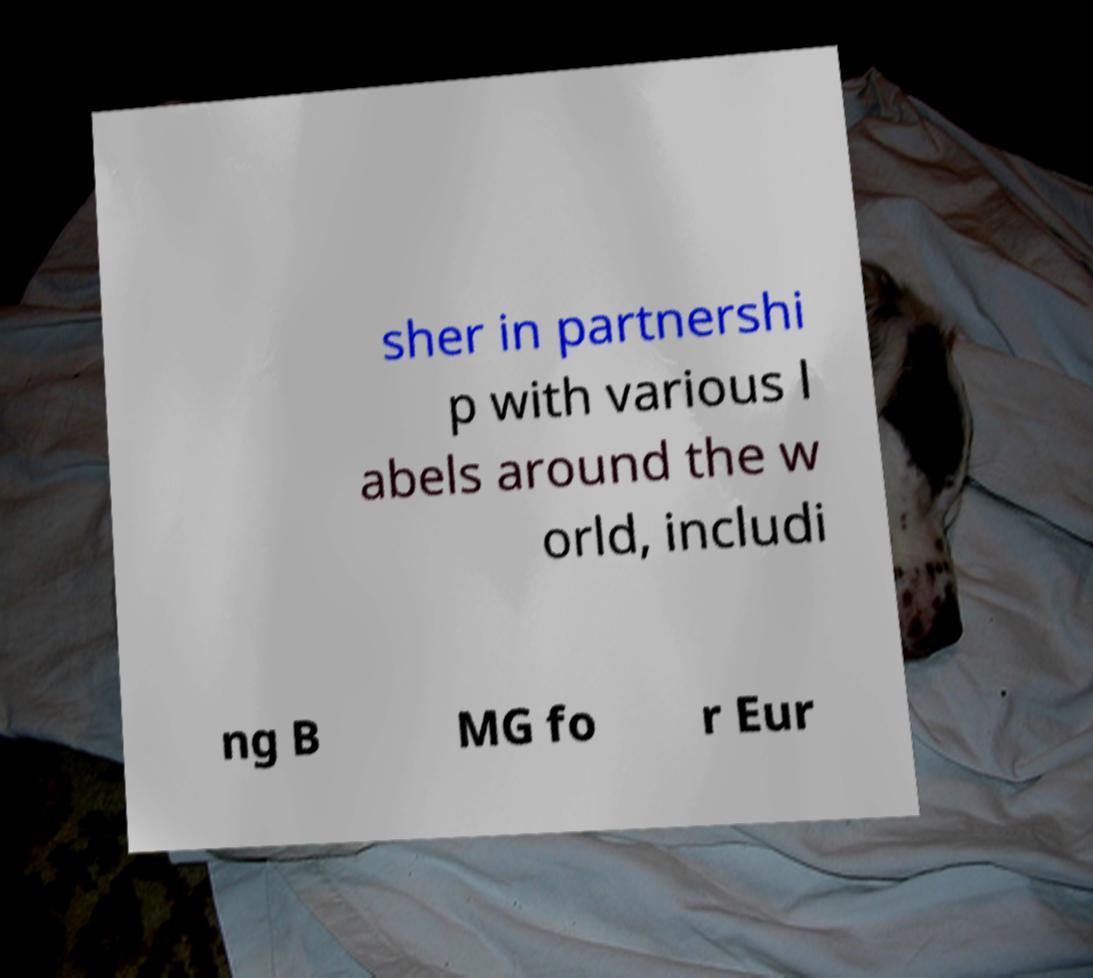For documentation purposes, I need the text within this image transcribed. Could you provide that? sher in partnershi p with various l abels around the w orld, includi ng B MG fo r Eur 